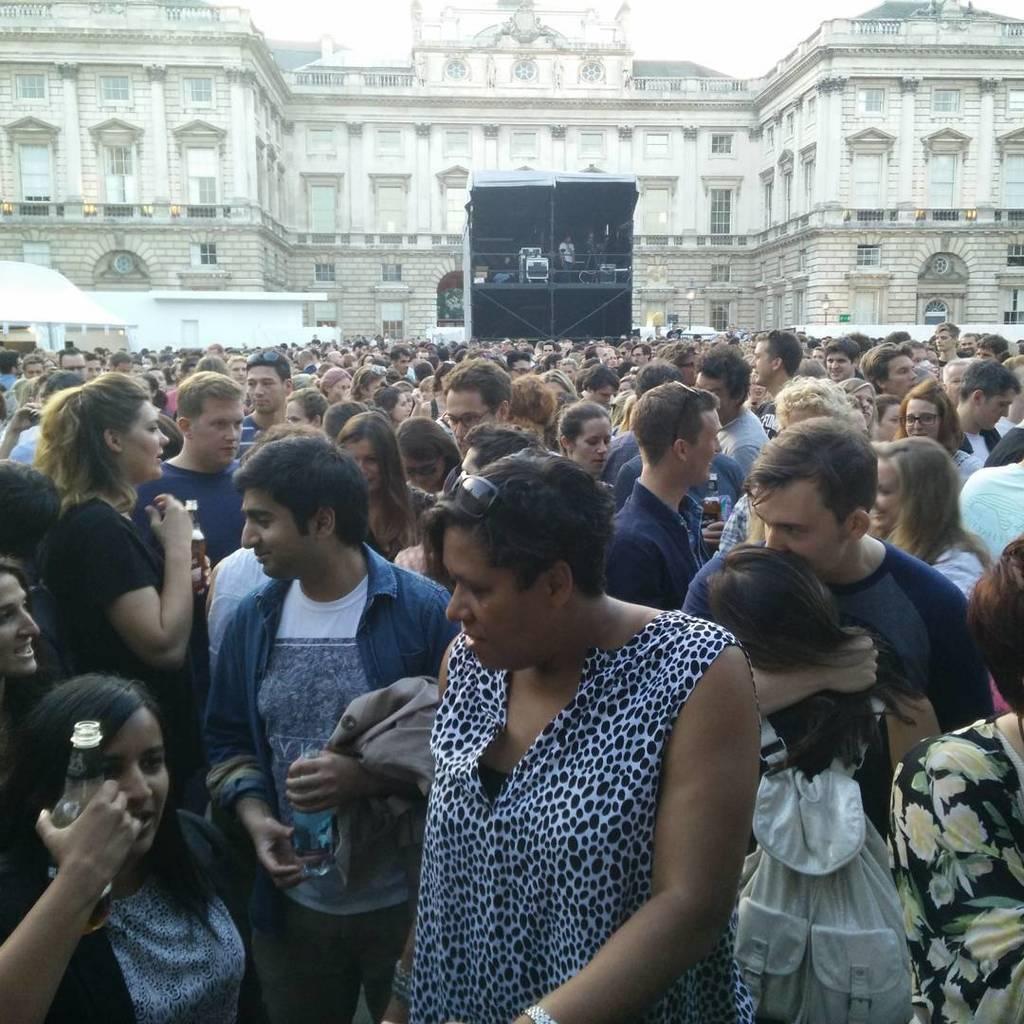Can you describe this image briefly? In the image there is a huge crowd and behind the crowd there is a massive building. 